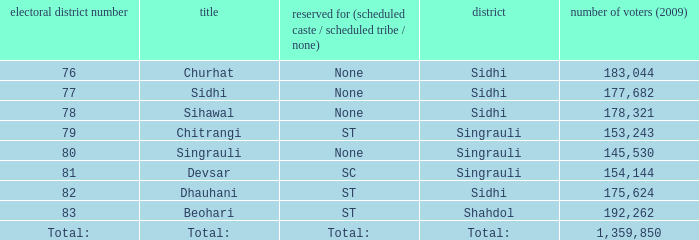What is Beohari's reserved for (SC/ST/None)? ST. 